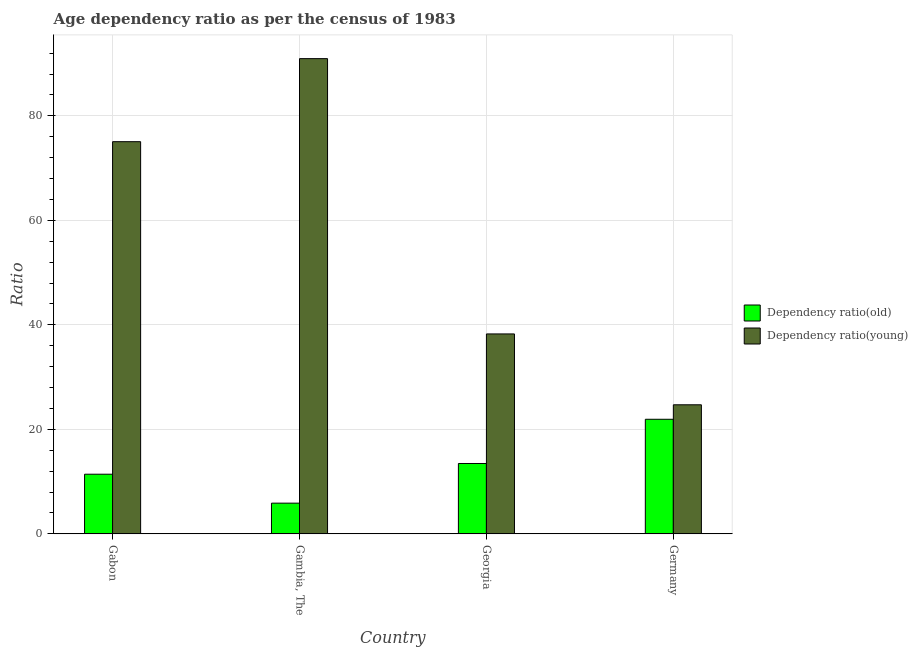How many groups of bars are there?
Ensure brevity in your answer.  4. Are the number of bars on each tick of the X-axis equal?
Provide a short and direct response. Yes. How many bars are there on the 1st tick from the left?
Offer a terse response. 2. What is the label of the 3rd group of bars from the left?
Make the answer very short. Georgia. What is the age dependency ratio(young) in Germany?
Ensure brevity in your answer.  24.7. Across all countries, what is the maximum age dependency ratio(old)?
Make the answer very short. 21.93. Across all countries, what is the minimum age dependency ratio(young)?
Offer a terse response. 24.7. In which country was the age dependency ratio(old) maximum?
Make the answer very short. Germany. In which country was the age dependency ratio(old) minimum?
Provide a succinct answer. Gambia, The. What is the total age dependency ratio(young) in the graph?
Your answer should be compact. 229. What is the difference between the age dependency ratio(young) in Gabon and that in Germany?
Offer a terse response. 50.36. What is the difference between the age dependency ratio(young) in Georgia and the age dependency ratio(old) in Gabon?
Make the answer very short. 26.85. What is the average age dependency ratio(old) per country?
Give a very brief answer. 13.17. What is the difference between the age dependency ratio(young) and age dependency ratio(old) in Germany?
Your response must be concise. 2.77. In how many countries, is the age dependency ratio(young) greater than 40 ?
Offer a terse response. 2. What is the ratio of the age dependency ratio(old) in Gabon to that in Germany?
Give a very brief answer. 0.52. What is the difference between the highest and the second highest age dependency ratio(old)?
Offer a very short reply. 8.46. What is the difference between the highest and the lowest age dependency ratio(young)?
Your answer should be very brief. 66.26. What does the 2nd bar from the left in Georgia represents?
Keep it short and to the point. Dependency ratio(young). What does the 2nd bar from the right in Georgia represents?
Your answer should be very brief. Dependency ratio(old). Are all the bars in the graph horizontal?
Your response must be concise. No. How many countries are there in the graph?
Keep it short and to the point. 4. What is the difference between two consecutive major ticks on the Y-axis?
Give a very brief answer. 20. Are the values on the major ticks of Y-axis written in scientific E-notation?
Offer a terse response. No. Does the graph contain grids?
Offer a very short reply. Yes. Where does the legend appear in the graph?
Ensure brevity in your answer.  Center right. What is the title of the graph?
Give a very brief answer. Age dependency ratio as per the census of 1983. Does "Urban agglomerations" appear as one of the legend labels in the graph?
Make the answer very short. No. What is the label or title of the X-axis?
Ensure brevity in your answer.  Country. What is the label or title of the Y-axis?
Your response must be concise. Ratio. What is the Ratio in Dependency ratio(old) in Gabon?
Make the answer very short. 11.42. What is the Ratio of Dependency ratio(young) in Gabon?
Provide a succinct answer. 75.06. What is the Ratio in Dependency ratio(old) in Gambia, The?
Ensure brevity in your answer.  5.88. What is the Ratio of Dependency ratio(young) in Gambia, The?
Your answer should be compact. 90.96. What is the Ratio in Dependency ratio(old) in Georgia?
Offer a terse response. 13.47. What is the Ratio in Dependency ratio(young) in Georgia?
Your response must be concise. 38.27. What is the Ratio of Dependency ratio(old) in Germany?
Offer a terse response. 21.93. What is the Ratio in Dependency ratio(young) in Germany?
Offer a very short reply. 24.7. Across all countries, what is the maximum Ratio of Dependency ratio(old)?
Ensure brevity in your answer.  21.93. Across all countries, what is the maximum Ratio in Dependency ratio(young)?
Offer a very short reply. 90.96. Across all countries, what is the minimum Ratio in Dependency ratio(old)?
Keep it short and to the point. 5.88. Across all countries, what is the minimum Ratio in Dependency ratio(young)?
Your response must be concise. 24.7. What is the total Ratio in Dependency ratio(old) in the graph?
Your answer should be very brief. 52.7. What is the total Ratio of Dependency ratio(young) in the graph?
Your answer should be compact. 229. What is the difference between the Ratio of Dependency ratio(old) in Gabon and that in Gambia, The?
Provide a short and direct response. 5.54. What is the difference between the Ratio in Dependency ratio(young) in Gabon and that in Gambia, The?
Provide a succinct answer. -15.9. What is the difference between the Ratio of Dependency ratio(old) in Gabon and that in Georgia?
Offer a terse response. -2.05. What is the difference between the Ratio of Dependency ratio(young) in Gabon and that in Georgia?
Offer a very short reply. 36.8. What is the difference between the Ratio in Dependency ratio(old) in Gabon and that in Germany?
Ensure brevity in your answer.  -10.51. What is the difference between the Ratio in Dependency ratio(young) in Gabon and that in Germany?
Give a very brief answer. 50.36. What is the difference between the Ratio in Dependency ratio(old) in Gambia, The and that in Georgia?
Offer a terse response. -7.59. What is the difference between the Ratio in Dependency ratio(young) in Gambia, The and that in Georgia?
Keep it short and to the point. 52.69. What is the difference between the Ratio of Dependency ratio(old) in Gambia, The and that in Germany?
Give a very brief answer. -16.05. What is the difference between the Ratio of Dependency ratio(young) in Gambia, The and that in Germany?
Your answer should be compact. 66.26. What is the difference between the Ratio in Dependency ratio(old) in Georgia and that in Germany?
Make the answer very short. -8.46. What is the difference between the Ratio of Dependency ratio(young) in Georgia and that in Germany?
Provide a succinct answer. 13.56. What is the difference between the Ratio in Dependency ratio(old) in Gabon and the Ratio in Dependency ratio(young) in Gambia, The?
Give a very brief answer. -79.54. What is the difference between the Ratio of Dependency ratio(old) in Gabon and the Ratio of Dependency ratio(young) in Georgia?
Give a very brief answer. -26.85. What is the difference between the Ratio in Dependency ratio(old) in Gabon and the Ratio in Dependency ratio(young) in Germany?
Keep it short and to the point. -13.29. What is the difference between the Ratio of Dependency ratio(old) in Gambia, The and the Ratio of Dependency ratio(young) in Georgia?
Keep it short and to the point. -32.39. What is the difference between the Ratio of Dependency ratio(old) in Gambia, The and the Ratio of Dependency ratio(young) in Germany?
Keep it short and to the point. -18.82. What is the difference between the Ratio in Dependency ratio(old) in Georgia and the Ratio in Dependency ratio(young) in Germany?
Your answer should be very brief. -11.24. What is the average Ratio in Dependency ratio(old) per country?
Your answer should be very brief. 13.17. What is the average Ratio of Dependency ratio(young) per country?
Give a very brief answer. 57.25. What is the difference between the Ratio in Dependency ratio(old) and Ratio in Dependency ratio(young) in Gabon?
Provide a succinct answer. -63.65. What is the difference between the Ratio of Dependency ratio(old) and Ratio of Dependency ratio(young) in Gambia, The?
Your answer should be very brief. -85.08. What is the difference between the Ratio in Dependency ratio(old) and Ratio in Dependency ratio(young) in Georgia?
Your answer should be compact. -24.8. What is the difference between the Ratio in Dependency ratio(old) and Ratio in Dependency ratio(young) in Germany?
Your answer should be very brief. -2.77. What is the ratio of the Ratio of Dependency ratio(old) in Gabon to that in Gambia, The?
Offer a very short reply. 1.94. What is the ratio of the Ratio in Dependency ratio(young) in Gabon to that in Gambia, The?
Give a very brief answer. 0.83. What is the ratio of the Ratio of Dependency ratio(old) in Gabon to that in Georgia?
Your answer should be compact. 0.85. What is the ratio of the Ratio of Dependency ratio(young) in Gabon to that in Georgia?
Offer a terse response. 1.96. What is the ratio of the Ratio in Dependency ratio(old) in Gabon to that in Germany?
Offer a terse response. 0.52. What is the ratio of the Ratio of Dependency ratio(young) in Gabon to that in Germany?
Provide a short and direct response. 3.04. What is the ratio of the Ratio in Dependency ratio(old) in Gambia, The to that in Georgia?
Your answer should be very brief. 0.44. What is the ratio of the Ratio in Dependency ratio(young) in Gambia, The to that in Georgia?
Offer a terse response. 2.38. What is the ratio of the Ratio in Dependency ratio(old) in Gambia, The to that in Germany?
Make the answer very short. 0.27. What is the ratio of the Ratio of Dependency ratio(young) in Gambia, The to that in Germany?
Provide a short and direct response. 3.68. What is the ratio of the Ratio of Dependency ratio(old) in Georgia to that in Germany?
Your answer should be very brief. 0.61. What is the ratio of the Ratio of Dependency ratio(young) in Georgia to that in Germany?
Your answer should be very brief. 1.55. What is the difference between the highest and the second highest Ratio in Dependency ratio(old)?
Provide a short and direct response. 8.46. What is the difference between the highest and the second highest Ratio of Dependency ratio(young)?
Make the answer very short. 15.9. What is the difference between the highest and the lowest Ratio of Dependency ratio(old)?
Your answer should be very brief. 16.05. What is the difference between the highest and the lowest Ratio of Dependency ratio(young)?
Ensure brevity in your answer.  66.26. 